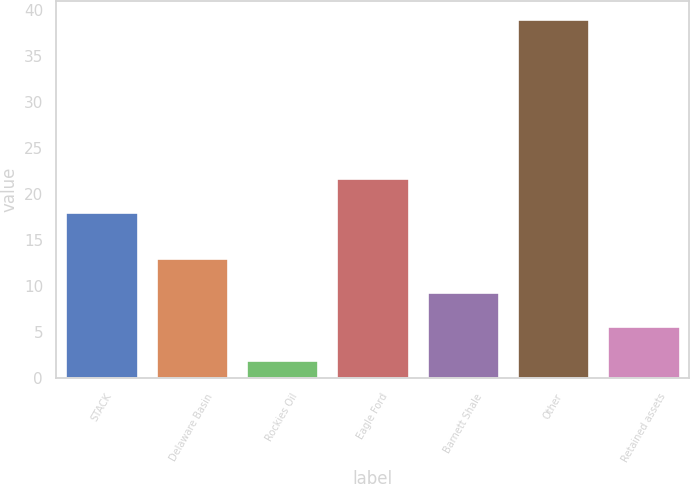Convert chart. <chart><loc_0><loc_0><loc_500><loc_500><bar_chart><fcel>STACK<fcel>Delaware Basin<fcel>Rockies Oil<fcel>Eagle Ford<fcel>Barnett Shale<fcel>Other<fcel>Retained assets<nl><fcel>18<fcel>13.1<fcel>2<fcel>21.7<fcel>9.4<fcel>39<fcel>5.7<nl></chart> 